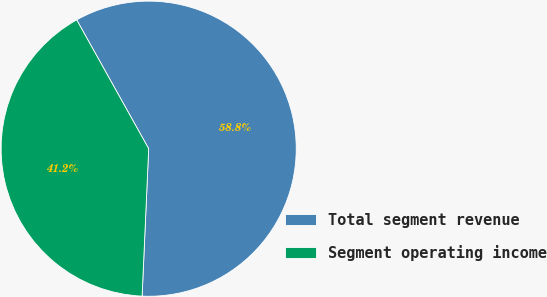<chart> <loc_0><loc_0><loc_500><loc_500><pie_chart><fcel>Total segment revenue<fcel>Segment operating income<nl><fcel>58.82%<fcel>41.18%<nl></chart> 